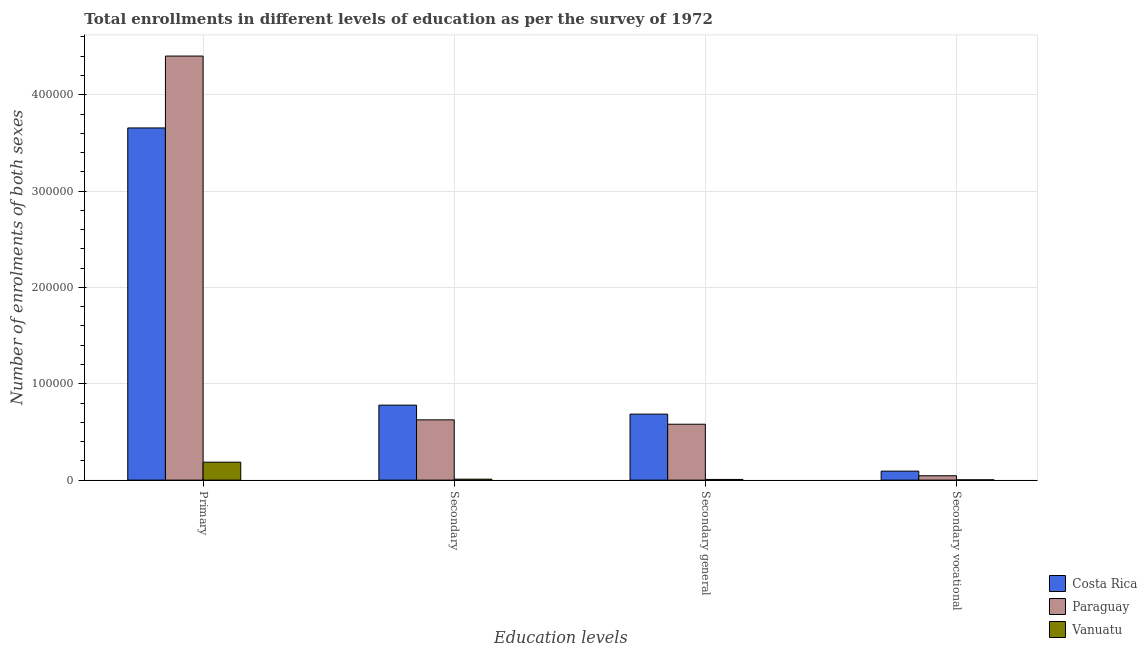How many different coloured bars are there?
Make the answer very short. 3. How many groups of bars are there?
Keep it short and to the point. 4. How many bars are there on the 4th tick from the right?
Ensure brevity in your answer.  3. What is the label of the 3rd group of bars from the left?
Your answer should be compact. Secondary general. What is the number of enrolments in secondary general education in Paraguay?
Offer a very short reply. 5.80e+04. Across all countries, what is the maximum number of enrolments in secondary education?
Offer a terse response. 7.78e+04. Across all countries, what is the minimum number of enrolments in secondary general education?
Give a very brief answer. 696. In which country was the number of enrolments in secondary education minimum?
Keep it short and to the point. Vanuatu. What is the total number of enrolments in primary education in the graph?
Your answer should be compact. 8.24e+05. What is the difference between the number of enrolments in secondary education in Vanuatu and that in Costa Rica?
Your response must be concise. -7.68e+04. What is the difference between the number of enrolments in primary education in Paraguay and the number of enrolments in secondary education in Vanuatu?
Ensure brevity in your answer.  4.39e+05. What is the average number of enrolments in secondary vocational education per country?
Offer a very short reply. 4714.67. What is the difference between the number of enrolments in secondary vocational education and number of enrolments in primary education in Costa Rica?
Keep it short and to the point. -3.56e+05. What is the ratio of the number of enrolments in secondary vocational education in Vanuatu to that in Costa Rica?
Provide a succinct answer. 0.03. Is the number of enrolments in secondary general education in Vanuatu less than that in Paraguay?
Give a very brief answer. Yes. Is the difference between the number of enrolments in primary education in Costa Rica and Paraguay greater than the difference between the number of enrolments in secondary education in Costa Rica and Paraguay?
Offer a terse response. No. What is the difference between the highest and the second highest number of enrolments in primary education?
Offer a very short reply. 7.46e+04. What is the difference between the highest and the lowest number of enrolments in secondary education?
Offer a terse response. 7.68e+04. In how many countries, is the number of enrolments in secondary education greater than the average number of enrolments in secondary education taken over all countries?
Your answer should be compact. 2. Is it the case that in every country, the sum of the number of enrolments in secondary vocational education and number of enrolments in secondary education is greater than the sum of number of enrolments in secondary general education and number of enrolments in primary education?
Offer a terse response. No. What does the 2nd bar from the left in Primary represents?
Provide a short and direct response. Paraguay. What does the 1st bar from the right in Primary represents?
Make the answer very short. Vanuatu. Are all the bars in the graph horizontal?
Your answer should be very brief. No. Does the graph contain grids?
Provide a succinct answer. Yes. How are the legend labels stacked?
Provide a succinct answer. Vertical. What is the title of the graph?
Offer a terse response. Total enrollments in different levels of education as per the survey of 1972. Does "Tajikistan" appear as one of the legend labels in the graph?
Your answer should be very brief. No. What is the label or title of the X-axis?
Ensure brevity in your answer.  Education levels. What is the label or title of the Y-axis?
Give a very brief answer. Number of enrolments of both sexes. What is the Number of enrolments of both sexes in Costa Rica in Primary?
Provide a short and direct response. 3.66e+05. What is the Number of enrolments of both sexes in Paraguay in Primary?
Provide a short and direct response. 4.40e+05. What is the Number of enrolments of both sexes in Vanuatu in Primary?
Keep it short and to the point. 1.86e+04. What is the Number of enrolments of both sexes of Costa Rica in Secondary?
Make the answer very short. 7.78e+04. What is the Number of enrolments of both sexes in Paraguay in Secondary?
Provide a short and direct response. 6.26e+04. What is the Number of enrolments of both sexes of Vanuatu in Secondary?
Make the answer very short. 980. What is the Number of enrolments of both sexes of Costa Rica in Secondary general?
Ensure brevity in your answer.  6.85e+04. What is the Number of enrolments of both sexes of Paraguay in Secondary general?
Make the answer very short. 5.80e+04. What is the Number of enrolments of both sexes in Vanuatu in Secondary general?
Offer a very short reply. 696. What is the Number of enrolments of both sexes of Costa Rica in Secondary vocational?
Ensure brevity in your answer.  9329. What is the Number of enrolments of both sexes of Paraguay in Secondary vocational?
Provide a succinct answer. 4531. What is the Number of enrolments of both sexes in Vanuatu in Secondary vocational?
Your response must be concise. 284. Across all Education levels, what is the maximum Number of enrolments of both sexes of Costa Rica?
Ensure brevity in your answer.  3.66e+05. Across all Education levels, what is the maximum Number of enrolments of both sexes in Paraguay?
Keep it short and to the point. 4.40e+05. Across all Education levels, what is the maximum Number of enrolments of both sexes in Vanuatu?
Your response must be concise. 1.86e+04. Across all Education levels, what is the minimum Number of enrolments of both sexes in Costa Rica?
Ensure brevity in your answer.  9329. Across all Education levels, what is the minimum Number of enrolments of both sexes in Paraguay?
Make the answer very short. 4531. Across all Education levels, what is the minimum Number of enrolments of both sexes of Vanuatu?
Provide a short and direct response. 284. What is the total Number of enrolments of both sexes in Costa Rica in the graph?
Keep it short and to the point. 5.21e+05. What is the total Number of enrolments of both sexes of Paraguay in the graph?
Provide a short and direct response. 5.65e+05. What is the total Number of enrolments of both sexes in Vanuatu in the graph?
Provide a short and direct response. 2.06e+04. What is the difference between the Number of enrolments of both sexes of Costa Rica in Primary and that in Secondary?
Keep it short and to the point. 2.88e+05. What is the difference between the Number of enrolments of both sexes in Paraguay in Primary and that in Secondary?
Your answer should be very brief. 3.78e+05. What is the difference between the Number of enrolments of both sexes in Vanuatu in Primary and that in Secondary?
Your answer should be compact. 1.76e+04. What is the difference between the Number of enrolments of both sexes in Costa Rica in Primary and that in Secondary general?
Your answer should be very brief. 2.97e+05. What is the difference between the Number of enrolments of both sexes of Paraguay in Primary and that in Secondary general?
Keep it short and to the point. 3.82e+05. What is the difference between the Number of enrolments of both sexes of Vanuatu in Primary and that in Secondary general?
Offer a very short reply. 1.79e+04. What is the difference between the Number of enrolments of both sexes of Costa Rica in Primary and that in Secondary vocational?
Offer a very short reply. 3.56e+05. What is the difference between the Number of enrolments of both sexes in Paraguay in Primary and that in Secondary vocational?
Your answer should be compact. 4.36e+05. What is the difference between the Number of enrolments of both sexes in Vanuatu in Primary and that in Secondary vocational?
Your response must be concise. 1.83e+04. What is the difference between the Number of enrolments of both sexes of Costa Rica in Secondary and that in Secondary general?
Your answer should be compact. 9329. What is the difference between the Number of enrolments of both sexes of Paraguay in Secondary and that in Secondary general?
Offer a terse response. 4531. What is the difference between the Number of enrolments of both sexes in Vanuatu in Secondary and that in Secondary general?
Your answer should be very brief. 284. What is the difference between the Number of enrolments of both sexes of Costa Rica in Secondary and that in Secondary vocational?
Your answer should be compact. 6.85e+04. What is the difference between the Number of enrolments of both sexes of Paraguay in Secondary and that in Secondary vocational?
Offer a terse response. 5.80e+04. What is the difference between the Number of enrolments of both sexes of Vanuatu in Secondary and that in Secondary vocational?
Offer a terse response. 696. What is the difference between the Number of enrolments of both sexes of Costa Rica in Secondary general and that in Secondary vocational?
Make the answer very short. 5.92e+04. What is the difference between the Number of enrolments of both sexes of Paraguay in Secondary general and that in Secondary vocational?
Your response must be concise. 5.35e+04. What is the difference between the Number of enrolments of both sexes in Vanuatu in Secondary general and that in Secondary vocational?
Your answer should be very brief. 412. What is the difference between the Number of enrolments of both sexes in Costa Rica in Primary and the Number of enrolments of both sexes in Paraguay in Secondary?
Give a very brief answer. 3.03e+05. What is the difference between the Number of enrolments of both sexes in Costa Rica in Primary and the Number of enrolments of both sexes in Vanuatu in Secondary?
Provide a succinct answer. 3.65e+05. What is the difference between the Number of enrolments of both sexes in Paraguay in Primary and the Number of enrolments of both sexes in Vanuatu in Secondary?
Provide a short and direct response. 4.39e+05. What is the difference between the Number of enrolments of both sexes of Costa Rica in Primary and the Number of enrolments of both sexes of Paraguay in Secondary general?
Your answer should be compact. 3.08e+05. What is the difference between the Number of enrolments of both sexes in Costa Rica in Primary and the Number of enrolments of both sexes in Vanuatu in Secondary general?
Offer a very short reply. 3.65e+05. What is the difference between the Number of enrolments of both sexes in Paraguay in Primary and the Number of enrolments of both sexes in Vanuatu in Secondary general?
Ensure brevity in your answer.  4.39e+05. What is the difference between the Number of enrolments of both sexes of Costa Rica in Primary and the Number of enrolments of both sexes of Paraguay in Secondary vocational?
Provide a succinct answer. 3.61e+05. What is the difference between the Number of enrolments of both sexes of Costa Rica in Primary and the Number of enrolments of both sexes of Vanuatu in Secondary vocational?
Offer a very short reply. 3.65e+05. What is the difference between the Number of enrolments of both sexes in Paraguay in Primary and the Number of enrolments of both sexes in Vanuatu in Secondary vocational?
Offer a very short reply. 4.40e+05. What is the difference between the Number of enrolments of both sexes in Costa Rica in Secondary and the Number of enrolments of both sexes in Paraguay in Secondary general?
Your answer should be compact. 1.98e+04. What is the difference between the Number of enrolments of both sexes in Costa Rica in Secondary and the Number of enrolments of both sexes in Vanuatu in Secondary general?
Offer a terse response. 7.71e+04. What is the difference between the Number of enrolments of both sexes of Paraguay in Secondary and the Number of enrolments of both sexes of Vanuatu in Secondary general?
Offer a terse response. 6.19e+04. What is the difference between the Number of enrolments of both sexes in Costa Rica in Secondary and the Number of enrolments of both sexes in Paraguay in Secondary vocational?
Provide a succinct answer. 7.33e+04. What is the difference between the Number of enrolments of both sexes in Costa Rica in Secondary and the Number of enrolments of both sexes in Vanuatu in Secondary vocational?
Your answer should be very brief. 7.75e+04. What is the difference between the Number of enrolments of both sexes in Paraguay in Secondary and the Number of enrolments of both sexes in Vanuatu in Secondary vocational?
Give a very brief answer. 6.23e+04. What is the difference between the Number of enrolments of both sexes of Costa Rica in Secondary general and the Number of enrolments of both sexes of Paraguay in Secondary vocational?
Make the answer very short. 6.40e+04. What is the difference between the Number of enrolments of both sexes of Costa Rica in Secondary general and the Number of enrolments of both sexes of Vanuatu in Secondary vocational?
Keep it short and to the point. 6.82e+04. What is the difference between the Number of enrolments of both sexes of Paraguay in Secondary general and the Number of enrolments of both sexes of Vanuatu in Secondary vocational?
Offer a terse response. 5.77e+04. What is the average Number of enrolments of both sexes of Costa Rica per Education levels?
Your answer should be compact. 1.30e+05. What is the average Number of enrolments of both sexes in Paraguay per Education levels?
Provide a succinct answer. 1.41e+05. What is the average Number of enrolments of both sexes of Vanuatu per Education levels?
Your answer should be very brief. 5145.5. What is the difference between the Number of enrolments of both sexes of Costa Rica and Number of enrolments of both sexes of Paraguay in Primary?
Make the answer very short. -7.46e+04. What is the difference between the Number of enrolments of both sexes in Costa Rica and Number of enrolments of both sexes in Vanuatu in Primary?
Your answer should be very brief. 3.47e+05. What is the difference between the Number of enrolments of both sexes of Paraguay and Number of enrolments of both sexes of Vanuatu in Primary?
Provide a succinct answer. 4.22e+05. What is the difference between the Number of enrolments of both sexes of Costa Rica and Number of enrolments of both sexes of Paraguay in Secondary?
Your answer should be compact. 1.53e+04. What is the difference between the Number of enrolments of both sexes of Costa Rica and Number of enrolments of both sexes of Vanuatu in Secondary?
Offer a terse response. 7.68e+04. What is the difference between the Number of enrolments of both sexes of Paraguay and Number of enrolments of both sexes of Vanuatu in Secondary?
Offer a very short reply. 6.16e+04. What is the difference between the Number of enrolments of both sexes of Costa Rica and Number of enrolments of both sexes of Paraguay in Secondary general?
Offer a terse response. 1.05e+04. What is the difference between the Number of enrolments of both sexes of Costa Rica and Number of enrolments of both sexes of Vanuatu in Secondary general?
Provide a succinct answer. 6.78e+04. What is the difference between the Number of enrolments of both sexes of Paraguay and Number of enrolments of both sexes of Vanuatu in Secondary general?
Your answer should be compact. 5.73e+04. What is the difference between the Number of enrolments of both sexes of Costa Rica and Number of enrolments of both sexes of Paraguay in Secondary vocational?
Your answer should be compact. 4798. What is the difference between the Number of enrolments of both sexes of Costa Rica and Number of enrolments of both sexes of Vanuatu in Secondary vocational?
Offer a very short reply. 9045. What is the difference between the Number of enrolments of both sexes in Paraguay and Number of enrolments of both sexes in Vanuatu in Secondary vocational?
Give a very brief answer. 4247. What is the ratio of the Number of enrolments of both sexes of Costa Rica in Primary to that in Secondary?
Your answer should be compact. 4.7. What is the ratio of the Number of enrolments of both sexes of Paraguay in Primary to that in Secondary?
Your answer should be very brief. 7.04. What is the ratio of the Number of enrolments of both sexes of Vanuatu in Primary to that in Secondary?
Your response must be concise. 19. What is the ratio of the Number of enrolments of both sexes in Costa Rica in Primary to that in Secondary general?
Your answer should be compact. 5.34. What is the ratio of the Number of enrolments of both sexes of Paraguay in Primary to that in Secondary general?
Keep it short and to the point. 7.59. What is the ratio of the Number of enrolments of both sexes of Vanuatu in Primary to that in Secondary general?
Offer a terse response. 26.76. What is the ratio of the Number of enrolments of both sexes of Costa Rica in Primary to that in Secondary vocational?
Your answer should be compact. 39.18. What is the ratio of the Number of enrolments of both sexes in Paraguay in Primary to that in Secondary vocational?
Keep it short and to the point. 97.14. What is the ratio of the Number of enrolments of both sexes of Vanuatu in Primary to that in Secondary vocational?
Offer a terse response. 65.57. What is the ratio of the Number of enrolments of both sexes in Costa Rica in Secondary to that in Secondary general?
Your answer should be very brief. 1.14. What is the ratio of the Number of enrolments of both sexes in Paraguay in Secondary to that in Secondary general?
Your response must be concise. 1.08. What is the ratio of the Number of enrolments of both sexes of Vanuatu in Secondary to that in Secondary general?
Provide a succinct answer. 1.41. What is the ratio of the Number of enrolments of both sexes in Costa Rica in Secondary to that in Secondary vocational?
Give a very brief answer. 8.34. What is the ratio of the Number of enrolments of both sexes in Paraguay in Secondary to that in Secondary vocational?
Your response must be concise. 13.81. What is the ratio of the Number of enrolments of both sexes in Vanuatu in Secondary to that in Secondary vocational?
Provide a succinct answer. 3.45. What is the ratio of the Number of enrolments of both sexes in Costa Rica in Secondary general to that in Secondary vocational?
Provide a short and direct response. 7.34. What is the ratio of the Number of enrolments of both sexes of Paraguay in Secondary general to that in Secondary vocational?
Provide a short and direct response. 12.81. What is the ratio of the Number of enrolments of both sexes of Vanuatu in Secondary general to that in Secondary vocational?
Offer a terse response. 2.45. What is the difference between the highest and the second highest Number of enrolments of both sexes in Costa Rica?
Give a very brief answer. 2.88e+05. What is the difference between the highest and the second highest Number of enrolments of both sexes of Paraguay?
Your answer should be compact. 3.78e+05. What is the difference between the highest and the second highest Number of enrolments of both sexes in Vanuatu?
Ensure brevity in your answer.  1.76e+04. What is the difference between the highest and the lowest Number of enrolments of both sexes in Costa Rica?
Provide a succinct answer. 3.56e+05. What is the difference between the highest and the lowest Number of enrolments of both sexes of Paraguay?
Your response must be concise. 4.36e+05. What is the difference between the highest and the lowest Number of enrolments of both sexes in Vanuatu?
Ensure brevity in your answer.  1.83e+04. 